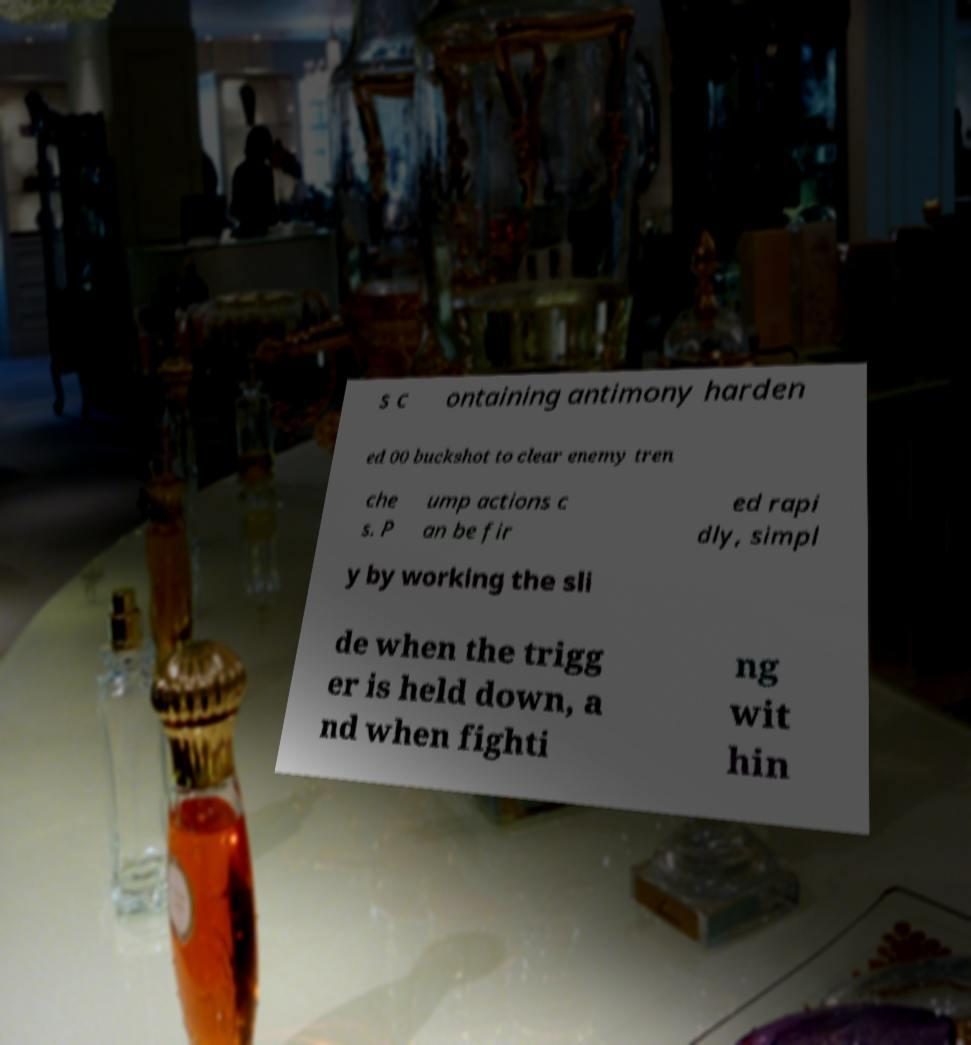There's text embedded in this image that I need extracted. Can you transcribe it verbatim? s c ontaining antimony harden ed 00 buckshot to clear enemy tren che s. P ump actions c an be fir ed rapi dly, simpl y by working the sli de when the trigg er is held down, a nd when fighti ng wit hin 